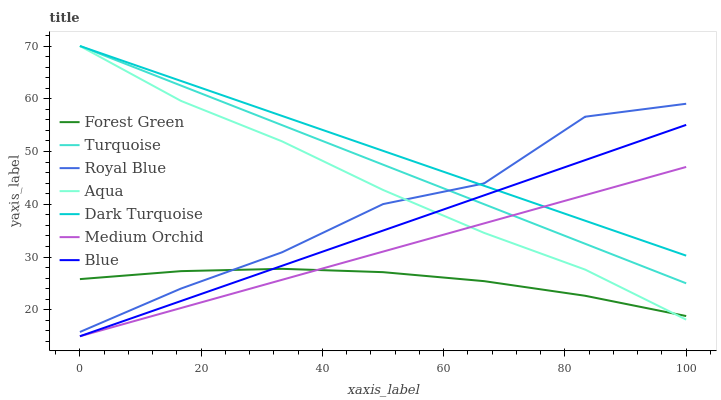Does Forest Green have the minimum area under the curve?
Answer yes or no. Yes. Does Dark Turquoise have the maximum area under the curve?
Answer yes or no. Yes. Does Turquoise have the minimum area under the curve?
Answer yes or no. No. Does Turquoise have the maximum area under the curve?
Answer yes or no. No. Is Dark Turquoise the smoothest?
Answer yes or no. Yes. Is Royal Blue the roughest?
Answer yes or no. Yes. Is Turquoise the smoothest?
Answer yes or no. No. Is Turquoise the roughest?
Answer yes or no. No. Does Turquoise have the lowest value?
Answer yes or no. No. Does Aqua have the highest value?
Answer yes or no. Yes. Does Medium Orchid have the highest value?
Answer yes or no. No. Is Forest Green less than Dark Turquoise?
Answer yes or no. Yes. Is Royal Blue greater than Medium Orchid?
Answer yes or no. Yes. Does Aqua intersect Blue?
Answer yes or no. Yes. Is Aqua less than Blue?
Answer yes or no. No. Is Aqua greater than Blue?
Answer yes or no. No. Does Forest Green intersect Dark Turquoise?
Answer yes or no. No. 